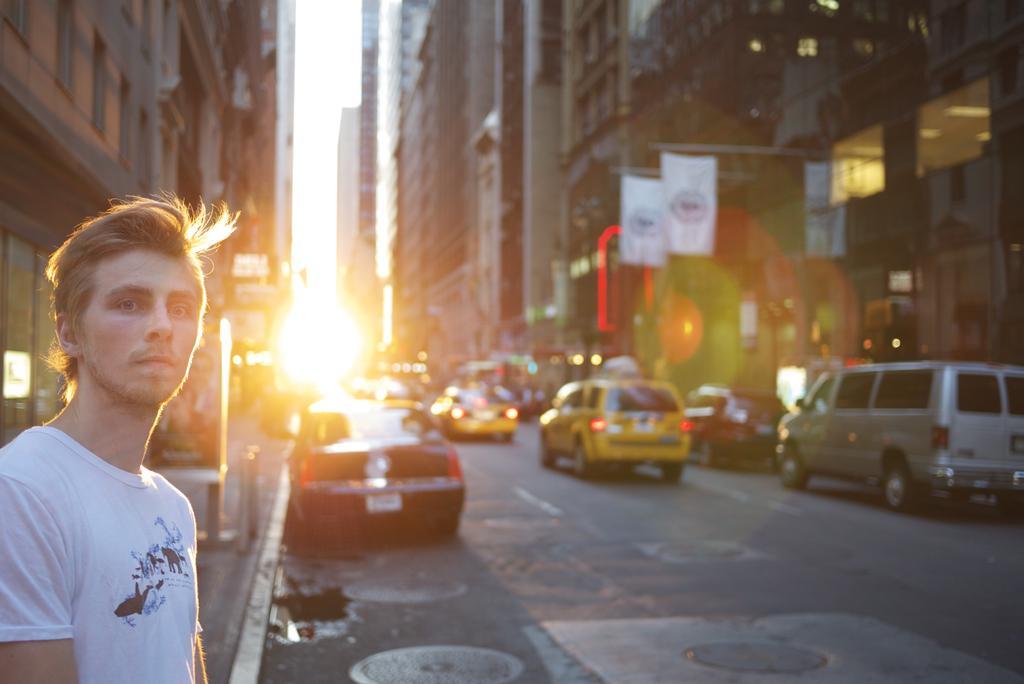Please provide a concise description of this image. In the left side a man is standing, he wore a white color t-shirt, there are few vehicles moving on this road and there are big buildings on either side of this road. 